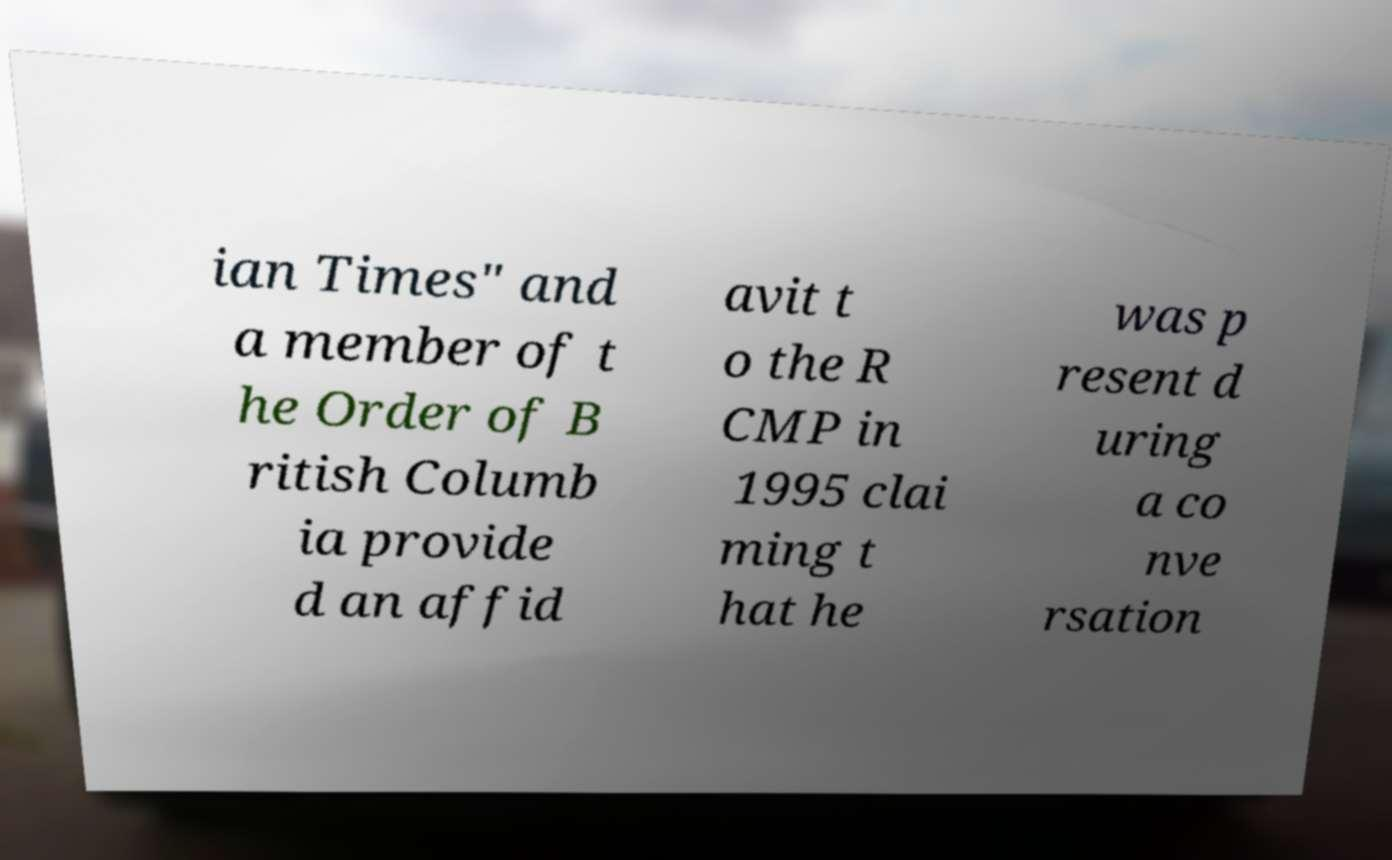Please read and relay the text visible in this image. What does it say? ian Times" and a member of t he Order of B ritish Columb ia provide d an affid avit t o the R CMP in 1995 clai ming t hat he was p resent d uring a co nve rsation 